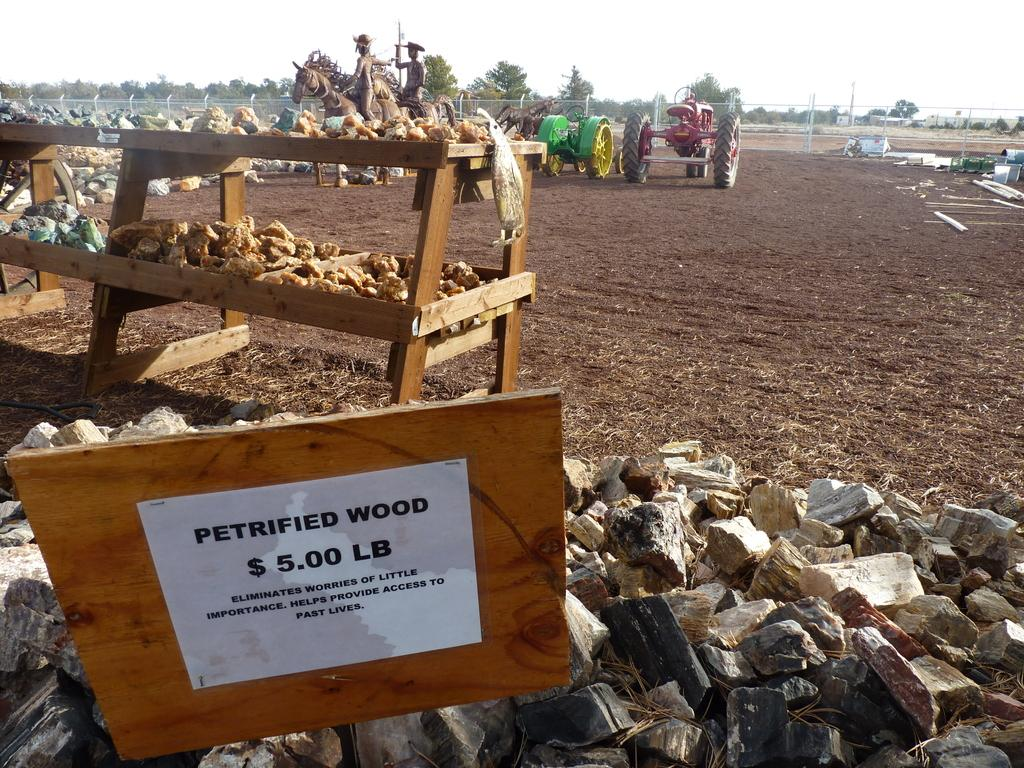<image>
Provide a brief description of the given image. A piece of wood with a sign advertising petrified wood stands on a pile of wood. 